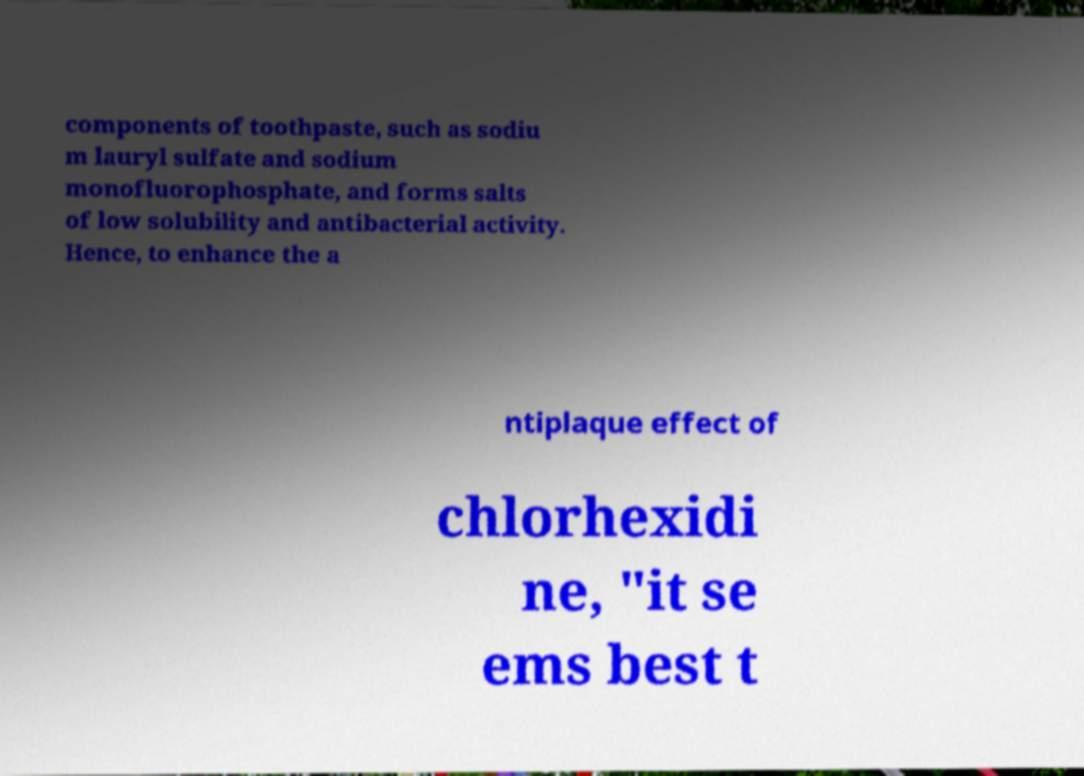Could you extract and type out the text from this image? components of toothpaste, such as sodiu m lauryl sulfate and sodium monofluorophosphate, and forms salts of low solubility and antibacterial activity. Hence, to enhance the a ntiplaque effect of chlorhexidi ne, "it se ems best t 